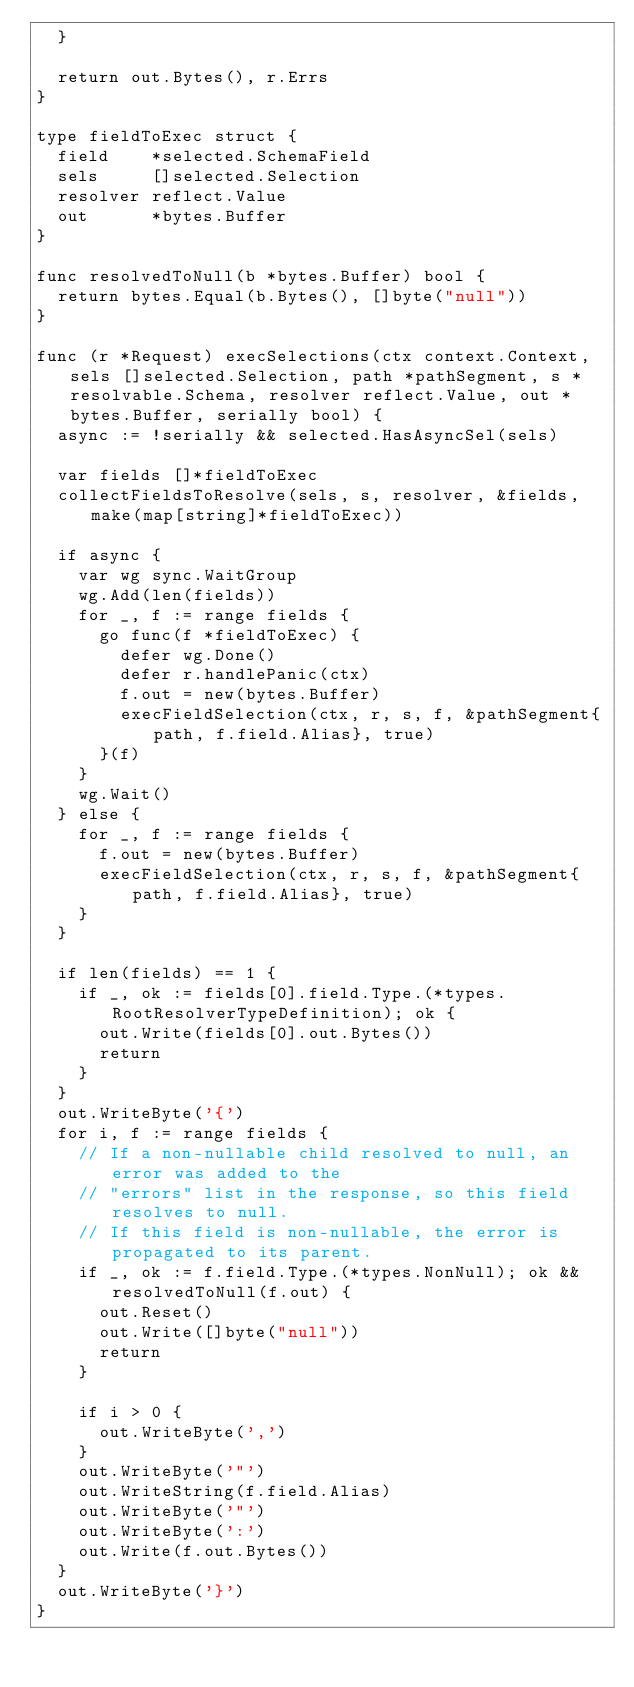<code> <loc_0><loc_0><loc_500><loc_500><_Go_>	}

	return out.Bytes(), r.Errs
}

type fieldToExec struct {
	field    *selected.SchemaField
	sels     []selected.Selection
	resolver reflect.Value
	out      *bytes.Buffer
}

func resolvedToNull(b *bytes.Buffer) bool {
	return bytes.Equal(b.Bytes(), []byte("null"))
}

func (r *Request) execSelections(ctx context.Context, sels []selected.Selection, path *pathSegment, s *resolvable.Schema, resolver reflect.Value, out *bytes.Buffer, serially bool) {
	async := !serially && selected.HasAsyncSel(sels)

	var fields []*fieldToExec
	collectFieldsToResolve(sels, s, resolver, &fields, make(map[string]*fieldToExec))

	if async {
		var wg sync.WaitGroup
		wg.Add(len(fields))
		for _, f := range fields {
			go func(f *fieldToExec) {
				defer wg.Done()
				defer r.handlePanic(ctx)
				f.out = new(bytes.Buffer)
				execFieldSelection(ctx, r, s, f, &pathSegment{path, f.field.Alias}, true)
			}(f)
		}
		wg.Wait()
	} else {
		for _, f := range fields {
			f.out = new(bytes.Buffer)
			execFieldSelection(ctx, r, s, f, &pathSegment{path, f.field.Alias}, true)
		}
	}

	if len(fields) == 1 {
		if _, ok := fields[0].field.Type.(*types.RootResolverTypeDefinition); ok {
			out.Write(fields[0].out.Bytes())
			return
		}
	}
	out.WriteByte('{')
	for i, f := range fields {
		// If a non-nullable child resolved to null, an error was added to the
		// "errors" list in the response, so this field resolves to null.
		// If this field is non-nullable, the error is propagated to its parent.
		if _, ok := f.field.Type.(*types.NonNull); ok && resolvedToNull(f.out) {
			out.Reset()
			out.Write([]byte("null"))
			return
		}

		if i > 0 {
			out.WriteByte(',')
		}
		out.WriteByte('"')
		out.WriteString(f.field.Alias)
		out.WriteByte('"')
		out.WriteByte(':')
		out.Write(f.out.Bytes())
	}
	out.WriteByte('}')
}
</code> 